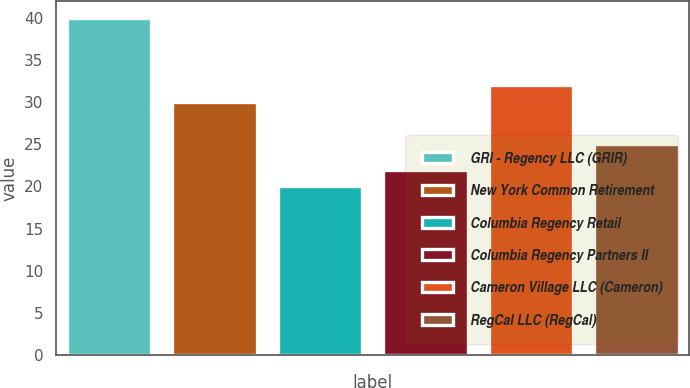Convert chart. <chart><loc_0><loc_0><loc_500><loc_500><bar_chart><fcel>GRI - Regency LLC (GRIR)<fcel>New York Common Retirement<fcel>Columbia Regency Retail<fcel>Columbia Regency Partners II<fcel>Cameron Village LLC (Cameron)<fcel>RegCal LLC (RegCal)<nl><fcel>40<fcel>30<fcel>20<fcel>22<fcel>32<fcel>25<nl></chart> 